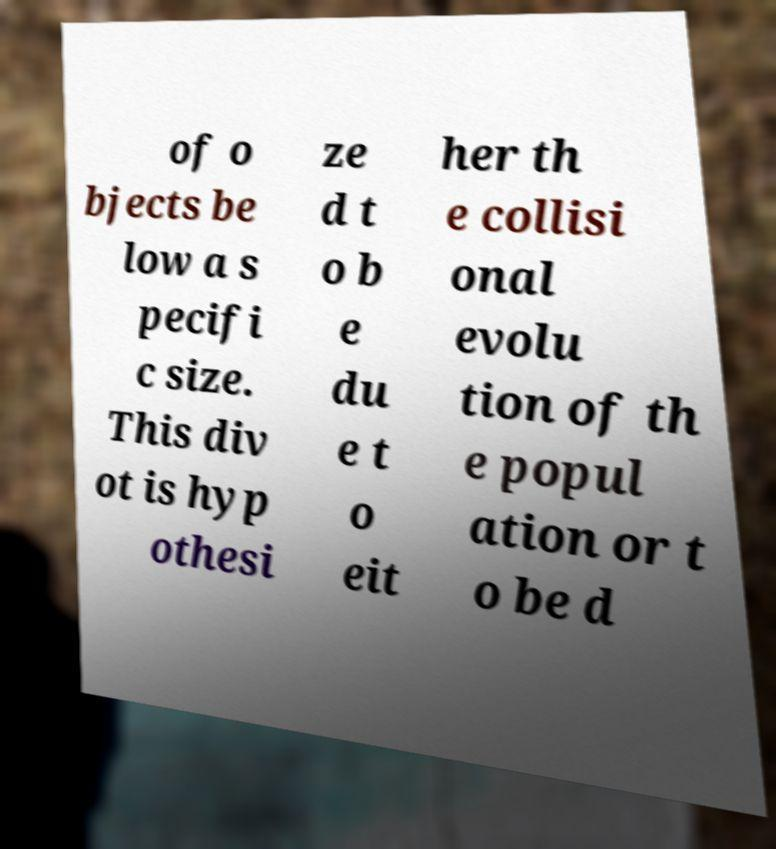Please identify and transcribe the text found in this image. of o bjects be low a s pecifi c size. This div ot is hyp othesi ze d t o b e du e t o eit her th e collisi onal evolu tion of th e popul ation or t o be d 